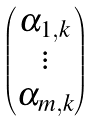Convert formula to latex. <formula><loc_0><loc_0><loc_500><loc_500>\begin{pmatrix} \alpha _ { 1 , k } \\ \vdots \\ \alpha _ { m , k } \end{pmatrix}</formula> 